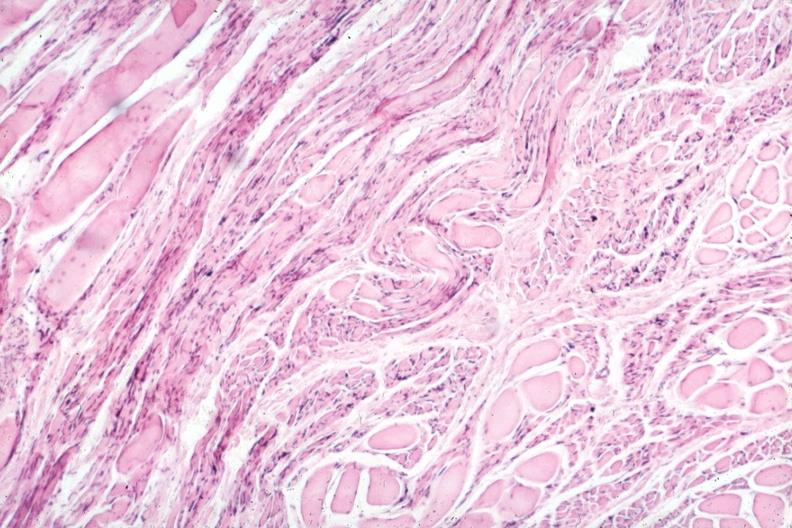s soft tissue present?
Answer the question using a single word or phrase. Yes 